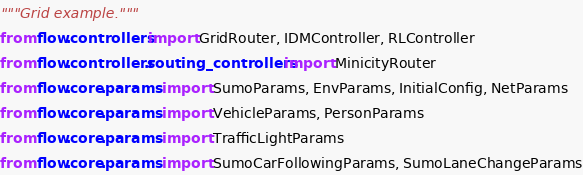<code> <loc_0><loc_0><loc_500><loc_500><_Python_>"""Grid example."""
from flow.controllers import GridRouter, IDMController, RLController
from flow.controllers.routing_controllers import MinicityRouter
from flow.core.params import SumoParams, EnvParams, InitialConfig, NetParams
from flow.core.params import VehicleParams, PersonParams
from flow.core.params import TrafficLightParams
from flow.core.params import SumoCarFollowingParams, SumoLaneChangeParams</code> 